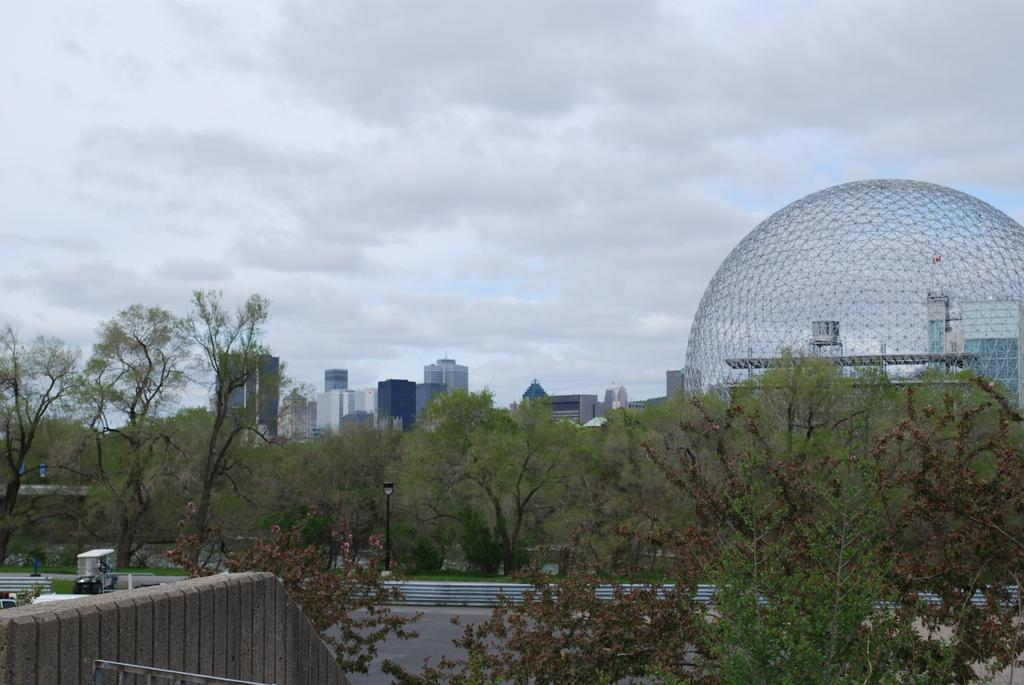What type of natural elements can be seen in the image? There are trees in the image. What type of man-made structures are present in the image? There are buildings in the image. What can be seen in the sky in the image? There are clouds in the image. What part of the natural environment is visible in the image? The sky is visible in the image. What is the black object in the image? There is a black pole in the image. What type of business is being conducted in the image? There is no indication of any business being conducted in the image. What mark can be seen on the trees in the image? There are no marks visible on the trees in the image. 